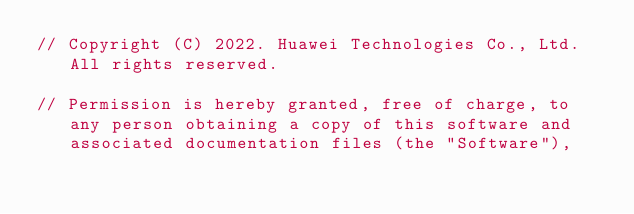Convert code to text. <code><loc_0><loc_0><loc_500><loc_500><_C_>// Copyright (C) 2022. Huawei Technologies Co., Ltd. All rights reserved.

// Permission is hereby granted, free of charge, to any person obtaining a copy of this software and associated documentation files (the "Software"),</code> 